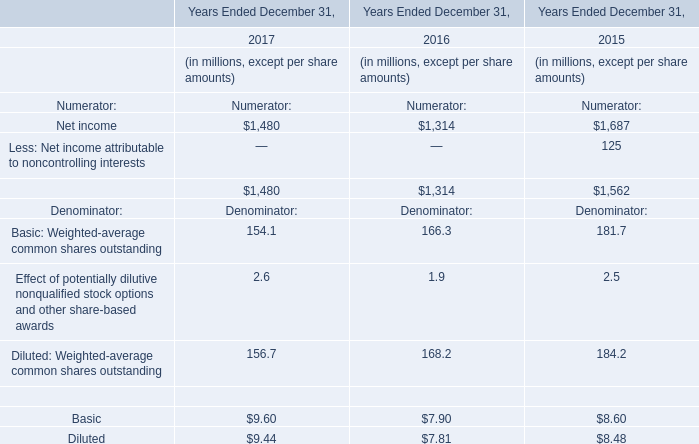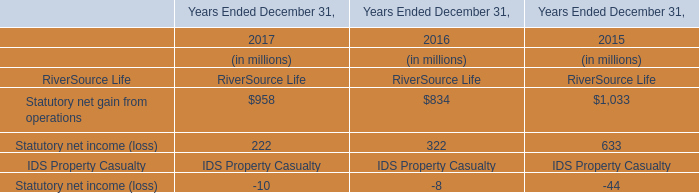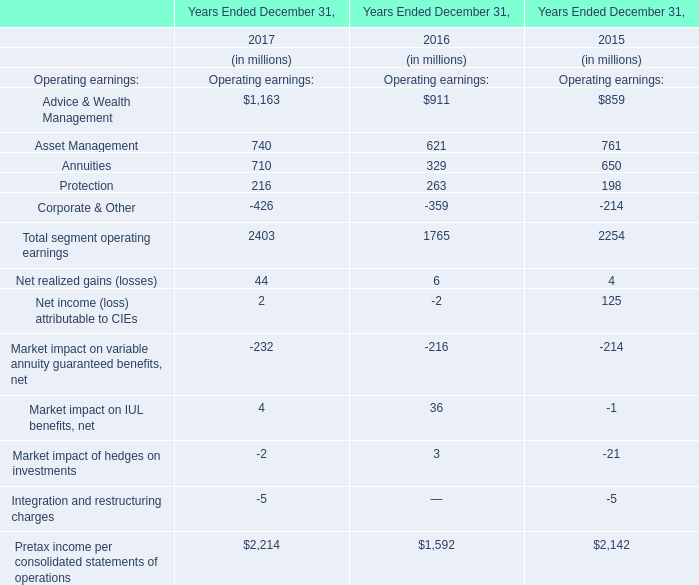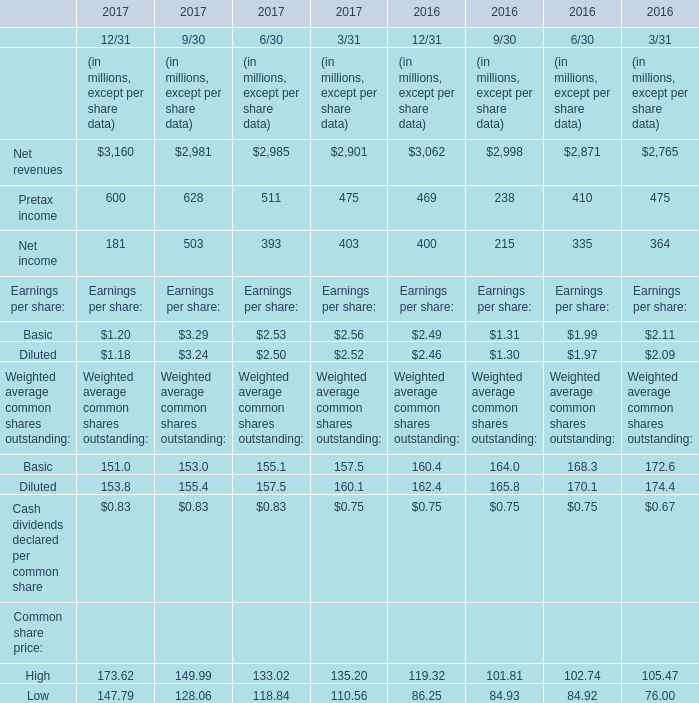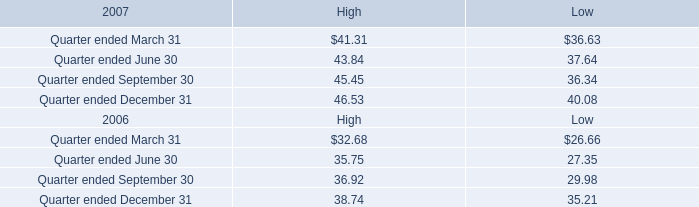What's the sum of Net revenues in 2017? (in million) 
Computations: (((3160 + 2981) + 2985) + 2901)
Answer: 12027.0. 